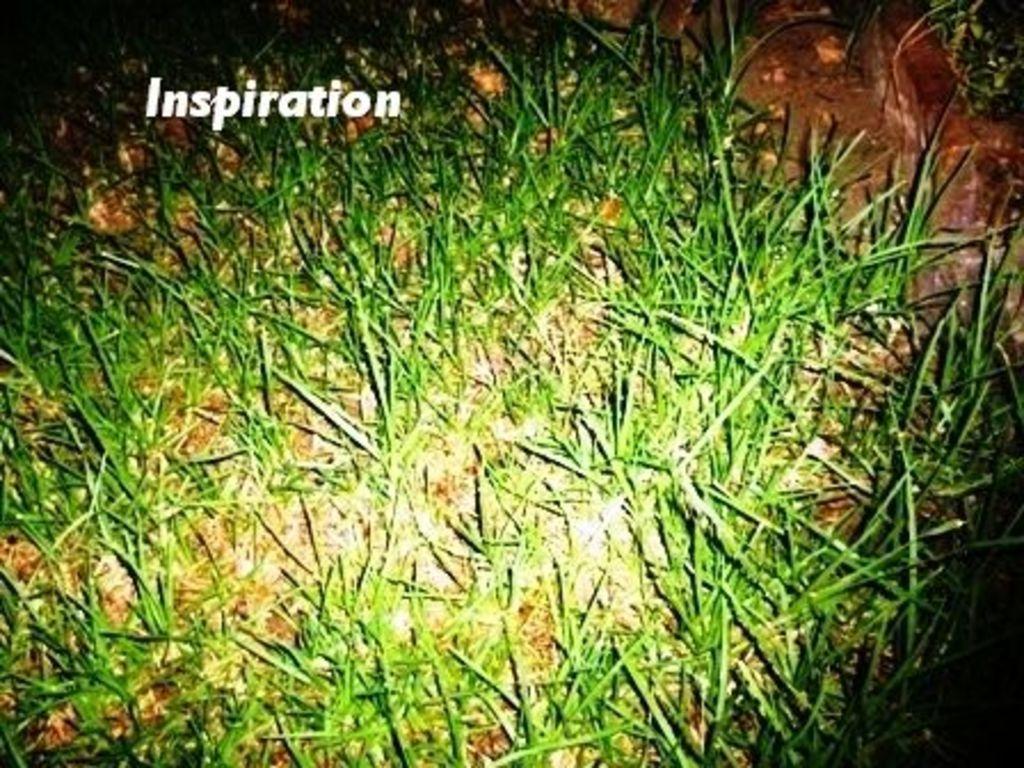How would you summarize this image in a sentence or two? In this image we can see grass, some mud and a text on the grass. 